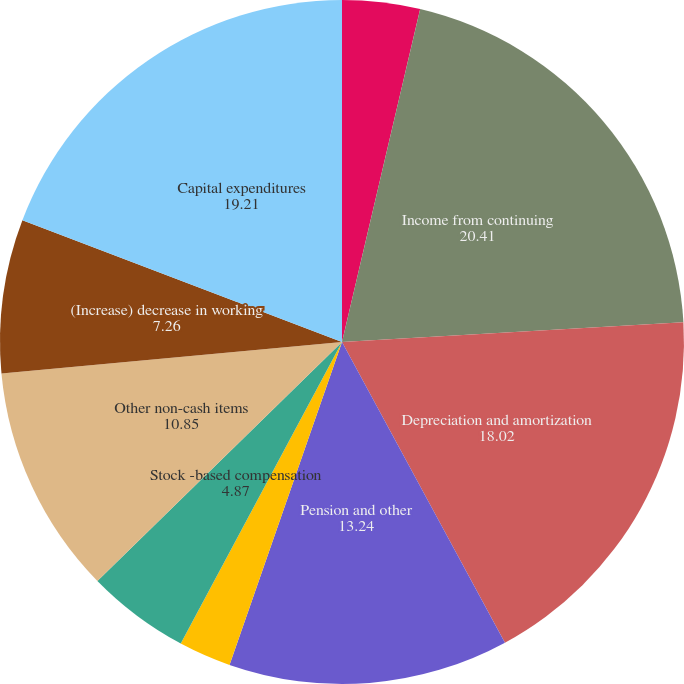Convert chart. <chart><loc_0><loc_0><loc_500><loc_500><pie_chart><fcel>Net Debt beginning of year<fcel>Income from continuing<fcel>Depreciation and amortization<fcel>Pension and other<fcel>Excess of equity income over<fcel>Stock -based compensation<fcel>Other non-cash items<fcel>(Increase) decrease in working<fcel>Capital expenditures<nl><fcel>3.67%<fcel>20.41%<fcel>18.02%<fcel>13.24%<fcel>2.48%<fcel>4.87%<fcel>10.85%<fcel>7.26%<fcel>19.21%<nl></chart> 